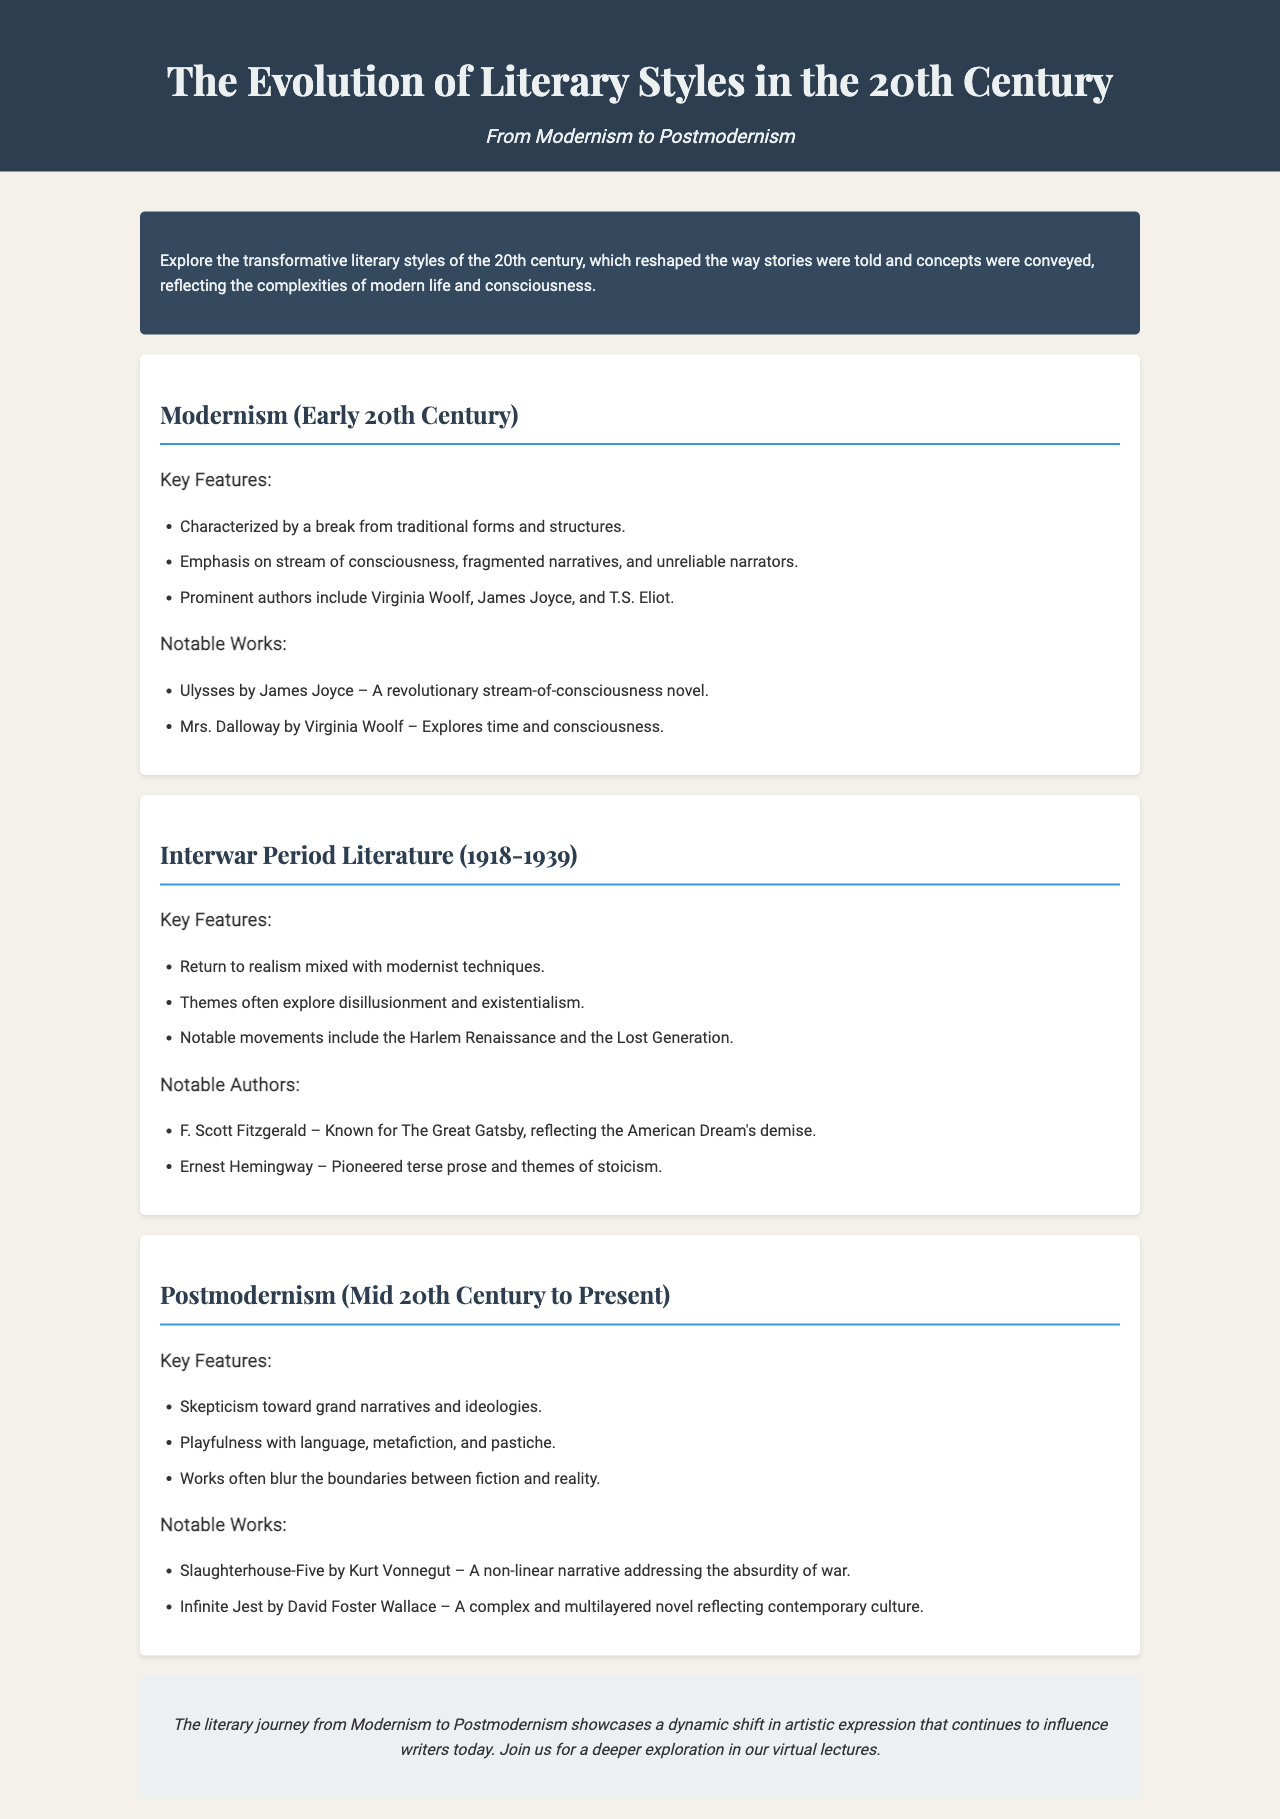What literary style is characterized by a break from traditional forms? The document outlines that Modernism is defined by a break from traditional forms and structures.
Answer: Modernism Who is a prominent author associated with Postmodernism? The brochure lists notable authors in the Postmodernism section, including Kurt Vonnegut and David Foster Wallace.
Answer: Kurt Vonnegut What is the notable work of Virginia Woolf mentioned in the document? The notable work listed under Virginia Woolf is "Mrs. Dalloway" in the Modernism section.
Answer: Mrs. Dalloway What years define the Interwar Period Literature? The document specifies the timeframe for Interwar Period Literature as 1918-1939.
Answer: 1918-1939 Which movement is highlighted as part of the Interwar Period Literature? The document mentions the Harlem Renaissance as a notable movement during this period.
Answer: Harlem Renaissance What theme is common in Interwar Period Literature according to the document? The document highlights themes of disillusionment and existentialism as common in this literature.
Answer: Disillusionment What narrative style is prevalent in "Slaughterhouse-Five"? The brochure states that the novel has a non-linear narrative style, characteristic of Postmodernism.
Answer: Non-linear What overarching theme does Postmodernism express skepticism toward? The document discusses Postmodernism's skepticism toward grand narratives and ideologies.
Answer: Grand narratives What type of literary expression does the document suggest continues to influence writers today? The conclusion indicates that the literary journey from Modernism to Postmodernism showcases a dynamic shift in artistic expression.
Answer: Dynamic shift 